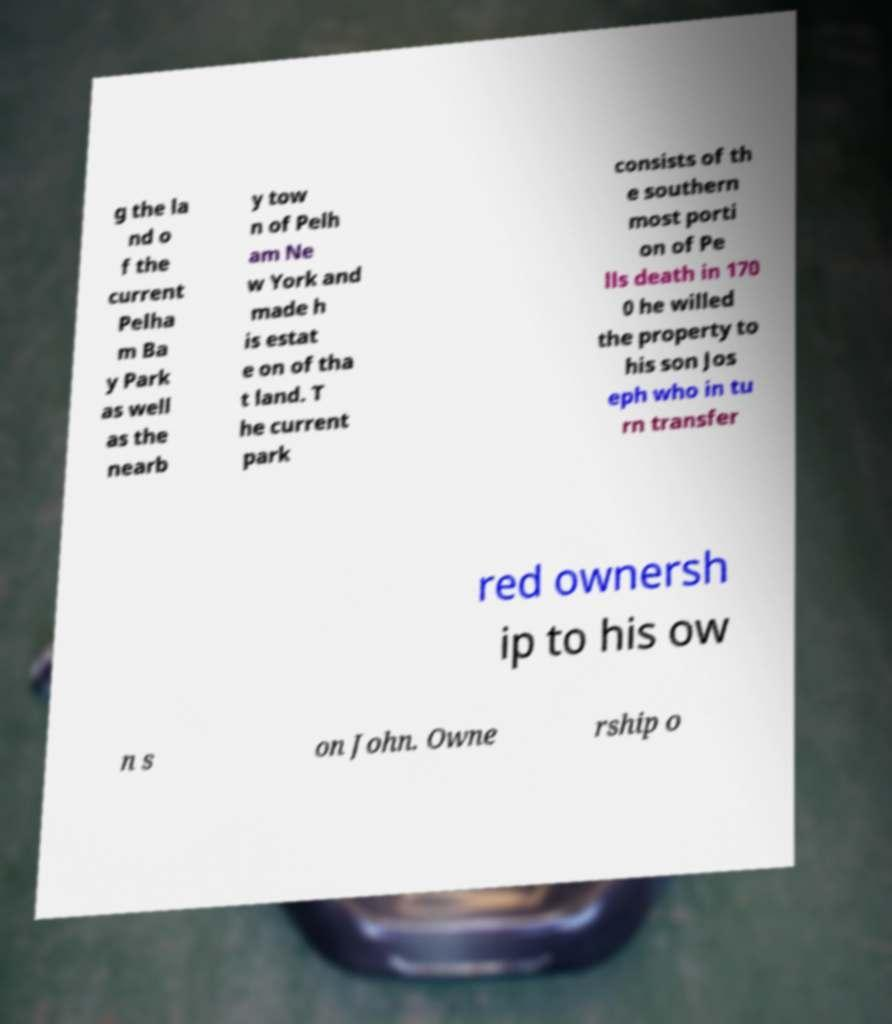Can you accurately transcribe the text from the provided image for me? g the la nd o f the current Pelha m Ba y Park as well as the nearb y tow n of Pelh am Ne w York and made h is estat e on of tha t land. T he current park consists of th e southern most porti on of Pe lls death in 170 0 he willed the property to his son Jos eph who in tu rn transfer red ownersh ip to his ow n s on John. Owne rship o 